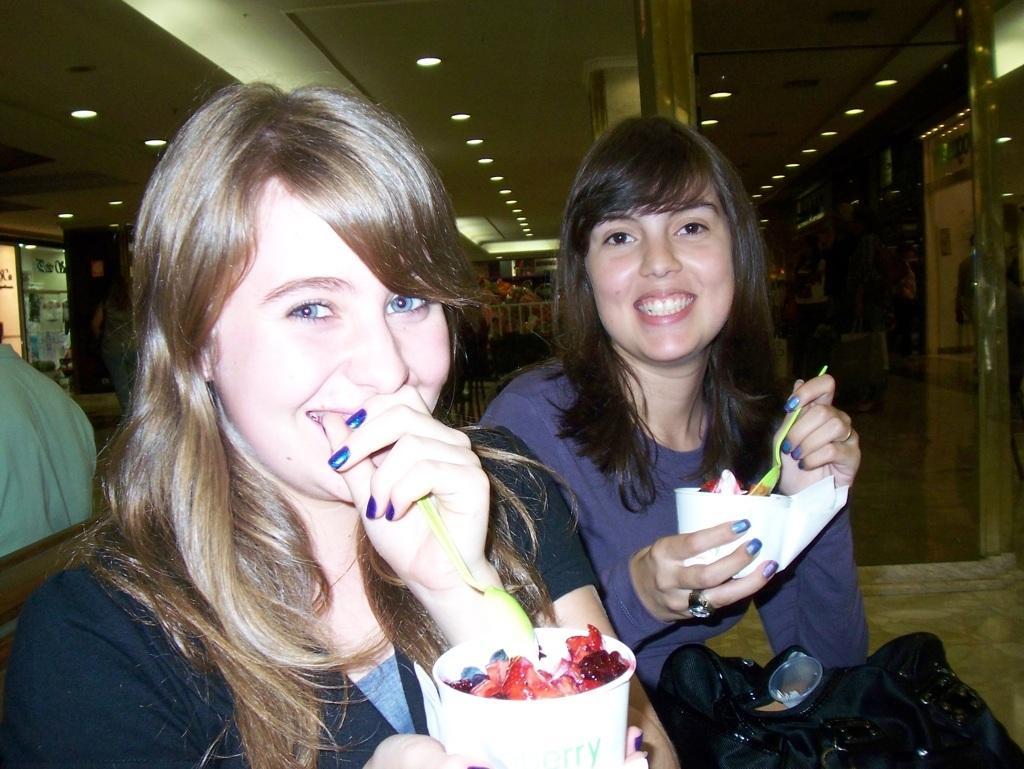Could you give a brief overview of what you see in this image? In the foreground of the picture we can see two women holding cups, spoons. In the cups there is food item. On the left we can see people, ceiling, light, racks and other objects. In the center of the background there are people, wall, ceiling and light. On the right there are people, shops, ceiling, light, floor and other objects. 